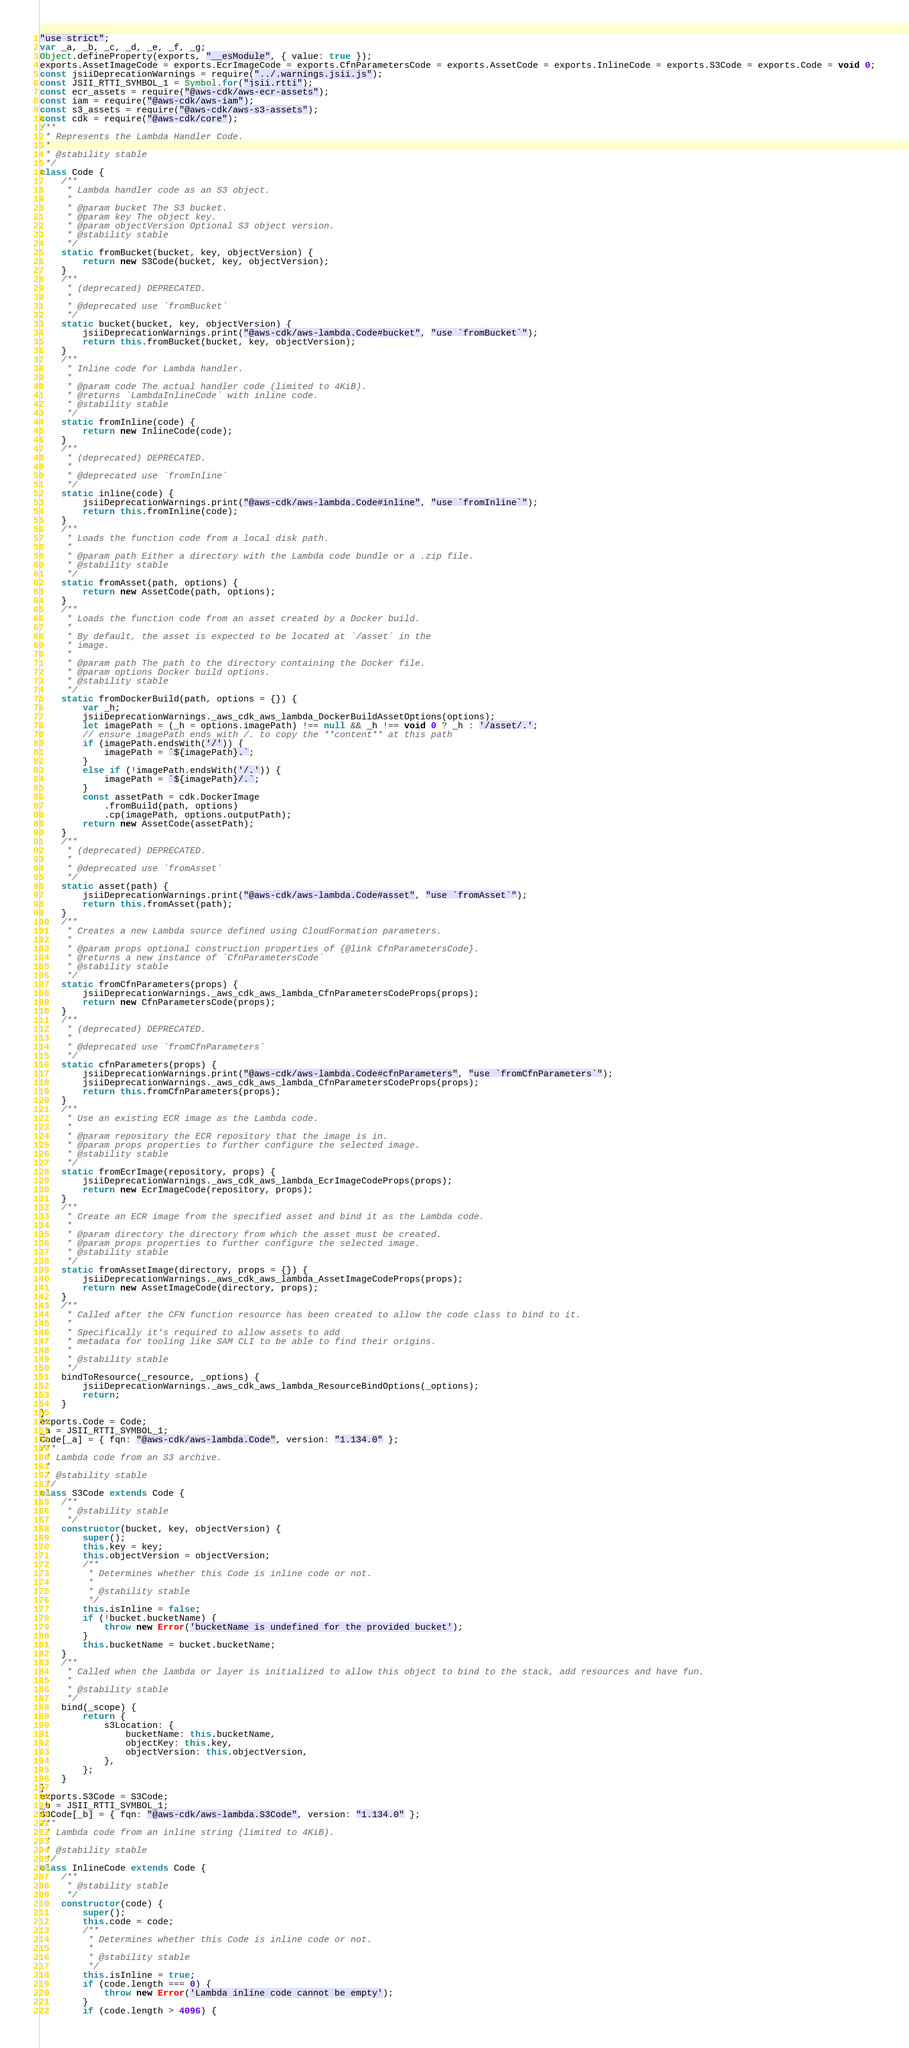Convert code to text. <code><loc_0><loc_0><loc_500><loc_500><_JavaScript_>"use strict";
var _a, _b, _c, _d, _e, _f, _g;
Object.defineProperty(exports, "__esModule", { value: true });
exports.AssetImageCode = exports.EcrImageCode = exports.CfnParametersCode = exports.AssetCode = exports.InlineCode = exports.S3Code = exports.Code = void 0;
const jsiiDeprecationWarnings = require("../.warnings.jsii.js");
const JSII_RTTI_SYMBOL_1 = Symbol.for("jsii.rtti");
const ecr_assets = require("@aws-cdk/aws-ecr-assets");
const iam = require("@aws-cdk/aws-iam");
const s3_assets = require("@aws-cdk/aws-s3-assets");
const cdk = require("@aws-cdk/core");
/**
 * Represents the Lambda Handler Code.
 *
 * @stability stable
 */
class Code {
    /**
     * Lambda handler code as an S3 object.
     *
     * @param bucket The S3 bucket.
     * @param key The object key.
     * @param objectVersion Optional S3 object version.
     * @stability stable
     */
    static fromBucket(bucket, key, objectVersion) {
        return new S3Code(bucket, key, objectVersion);
    }
    /**
     * (deprecated) DEPRECATED.
     *
     * @deprecated use `fromBucket`
     */
    static bucket(bucket, key, objectVersion) {
        jsiiDeprecationWarnings.print("@aws-cdk/aws-lambda.Code#bucket", "use `fromBucket`");
        return this.fromBucket(bucket, key, objectVersion);
    }
    /**
     * Inline code for Lambda handler.
     *
     * @param code The actual handler code (limited to 4KiB).
     * @returns `LambdaInlineCode` with inline code.
     * @stability stable
     */
    static fromInline(code) {
        return new InlineCode(code);
    }
    /**
     * (deprecated) DEPRECATED.
     *
     * @deprecated use `fromInline`
     */
    static inline(code) {
        jsiiDeprecationWarnings.print("@aws-cdk/aws-lambda.Code#inline", "use `fromInline`");
        return this.fromInline(code);
    }
    /**
     * Loads the function code from a local disk path.
     *
     * @param path Either a directory with the Lambda code bundle or a .zip file.
     * @stability stable
     */
    static fromAsset(path, options) {
        return new AssetCode(path, options);
    }
    /**
     * Loads the function code from an asset created by a Docker build.
     *
     * By default, the asset is expected to be located at `/asset` in the
     * image.
     *
     * @param path The path to the directory containing the Docker file.
     * @param options Docker build options.
     * @stability stable
     */
    static fromDockerBuild(path, options = {}) {
        var _h;
        jsiiDeprecationWarnings._aws_cdk_aws_lambda_DockerBuildAssetOptions(options);
        let imagePath = (_h = options.imagePath) !== null && _h !== void 0 ? _h : '/asset/.';
        // ensure imagePath ends with /. to copy the **content** at this path
        if (imagePath.endsWith('/')) {
            imagePath = `${imagePath}.`;
        }
        else if (!imagePath.endsWith('/.')) {
            imagePath = `${imagePath}/.`;
        }
        const assetPath = cdk.DockerImage
            .fromBuild(path, options)
            .cp(imagePath, options.outputPath);
        return new AssetCode(assetPath);
    }
    /**
     * (deprecated) DEPRECATED.
     *
     * @deprecated use `fromAsset`
     */
    static asset(path) {
        jsiiDeprecationWarnings.print("@aws-cdk/aws-lambda.Code#asset", "use `fromAsset`");
        return this.fromAsset(path);
    }
    /**
     * Creates a new Lambda source defined using CloudFormation parameters.
     *
     * @param props optional construction properties of {@link CfnParametersCode}.
     * @returns a new instance of `CfnParametersCode`
     * @stability stable
     */
    static fromCfnParameters(props) {
        jsiiDeprecationWarnings._aws_cdk_aws_lambda_CfnParametersCodeProps(props);
        return new CfnParametersCode(props);
    }
    /**
     * (deprecated) DEPRECATED.
     *
     * @deprecated use `fromCfnParameters`
     */
    static cfnParameters(props) {
        jsiiDeprecationWarnings.print("@aws-cdk/aws-lambda.Code#cfnParameters", "use `fromCfnParameters`");
        jsiiDeprecationWarnings._aws_cdk_aws_lambda_CfnParametersCodeProps(props);
        return this.fromCfnParameters(props);
    }
    /**
     * Use an existing ECR image as the Lambda code.
     *
     * @param repository the ECR repository that the image is in.
     * @param props properties to further configure the selected image.
     * @stability stable
     */
    static fromEcrImage(repository, props) {
        jsiiDeprecationWarnings._aws_cdk_aws_lambda_EcrImageCodeProps(props);
        return new EcrImageCode(repository, props);
    }
    /**
     * Create an ECR image from the specified asset and bind it as the Lambda code.
     *
     * @param directory the directory from which the asset must be created.
     * @param props properties to further configure the selected image.
     * @stability stable
     */
    static fromAssetImage(directory, props = {}) {
        jsiiDeprecationWarnings._aws_cdk_aws_lambda_AssetImageCodeProps(props);
        return new AssetImageCode(directory, props);
    }
    /**
     * Called after the CFN function resource has been created to allow the code class to bind to it.
     *
     * Specifically it's required to allow assets to add
     * metadata for tooling like SAM CLI to be able to find their origins.
     *
     * @stability stable
     */
    bindToResource(_resource, _options) {
        jsiiDeprecationWarnings._aws_cdk_aws_lambda_ResourceBindOptions(_options);
        return;
    }
}
exports.Code = Code;
_a = JSII_RTTI_SYMBOL_1;
Code[_a] = { fqn: "@aws-cdk/aws-lambda.Code", version: "1.134.0" };
/**
 * Lambda code from an S3 archive.
 *
 * @stability stable
 */
class S3Code extends Code {
    /**
     * @stability stable
     */
    constructor(bucket, key, objectVersion) {
        super();
        this.key = key;
        this.objectVersion = objectVersion;
        /**
         * Determines whether this Code is inline code or not.
         *
         * @stability stable
         */
        this.isInline = false;
        if (!bucket.bucketName) {
            throw new Error('bucketName is undefined for the provided bucket');
        }
        this.bucketName = bucket.bucketName;
    }
    /**
     * Called when the lambda or layer is initialized to allow this object to bind to the stack, add resources and have fun.
     *
     * @stability stable
     */
    bind(_scope) {
        return {
            s3Location: {
                bucketName: this.bucketName,
                objectKey: this.key,
                objectVersion: this.objectVersion,
            },
        };
    }
}
exports.S3Code = S3Code;
_b = JSII_RTTI_SYMBOL_1;
S3Code[_b] = { fqn: "@aws-cdk/aws-lambda.S3Code", version: "1.134.0" };
/**
 * Lambda code from an inline string (limited to 4KiB).
 *
 * @stability stable
 */
class InlineCode extends Code {
    /**
     * @stability stable
     */
    constructor(code) {
        super();
        this.code = code;
        /**
         * Determines whether this Code is inline code or not.
         *
         * @stability stable
         */
        this.isInline = true;
        if (code.length === 0) {
            throw new Error('Lambda inline code cannot be empty');
        }
        if (code.length > 4096) {</code> 